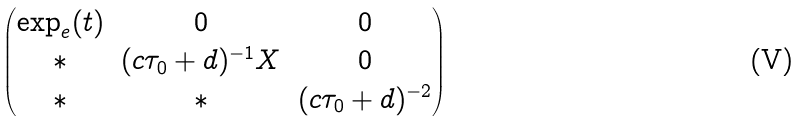Convert formula to latex. <formula><loc_0><loc_0><loc_500><loc_500>\begin{pmatrix} \exp _ { e } ( t ) & 0 & 0 \\ * & ( c \tau _ { 0 } + d ) ^ { - 1 } X & 0 \\ * & * & ( c \tau _ { 0 } + d ) ^ { - 2 } \end{pmatrix}</formula> 